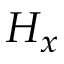Convert formula to latex. <formula><loc_0><loc_0><loc_500><loc_500>H _ { x }</formula> 